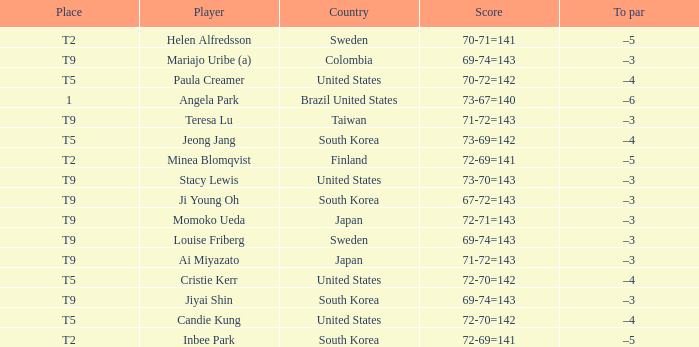I'm looking to parse the entire table for insights. Could you assist me with that? {'header': ['Place', 'Player', 'Country', 'Score', 'To par'], 'rows': [['T2', 'Helen Alfredsson', 'Sweden', '70-71=141', '–5'], ['T9', 'Mariajo Uribe (a)', 'Colombia', '69-74=143', '–3'], ['T5', 'Paula Creamer', 'United States', '70-72=142', '–4'], ['1', 'Angela Park', 'Brazil United States', '73-67=140', '–6'], ['T9', 'Teresa Lu', 'Taiwan', '71-72=143', '–3'], ['T5', 'Jeong Jang', 'South Korea', '73-69=142', '–4'], ['T2', 'Minea Blomqvist', 'Finland', '72-69=141', '–5'], ['T9', 'Stacy Lewis', 'United States', '73-70=143', '–3'], ['T9', 'Ji Young Oh', 'South Korea', '67-72=143', '–3'], ['T9', 'Momoko Ueda', 'Japan', '72-71=143', '–3'], ['T9', 'Louise Friberg', 'Sweden', '69-74=143', '–3'], ['T9', 'Ai Miyazato', 'Japan', '71-72=143', '–3'], ['T5', 'Cristie Kerr', 'United States', '72-70=142', '–4'], ['T9', 'Jiyai Shin', 'South Korea', '69-74=143', '–3'], ['T5', 'Candie Kung', 'United States', '72-70=142', '–4'], ['T2', 'Inbee Park', 'South Korea', '72-69=141', '–5']]} Which country placed t9 and had the player jiyai shin? South Korea. 